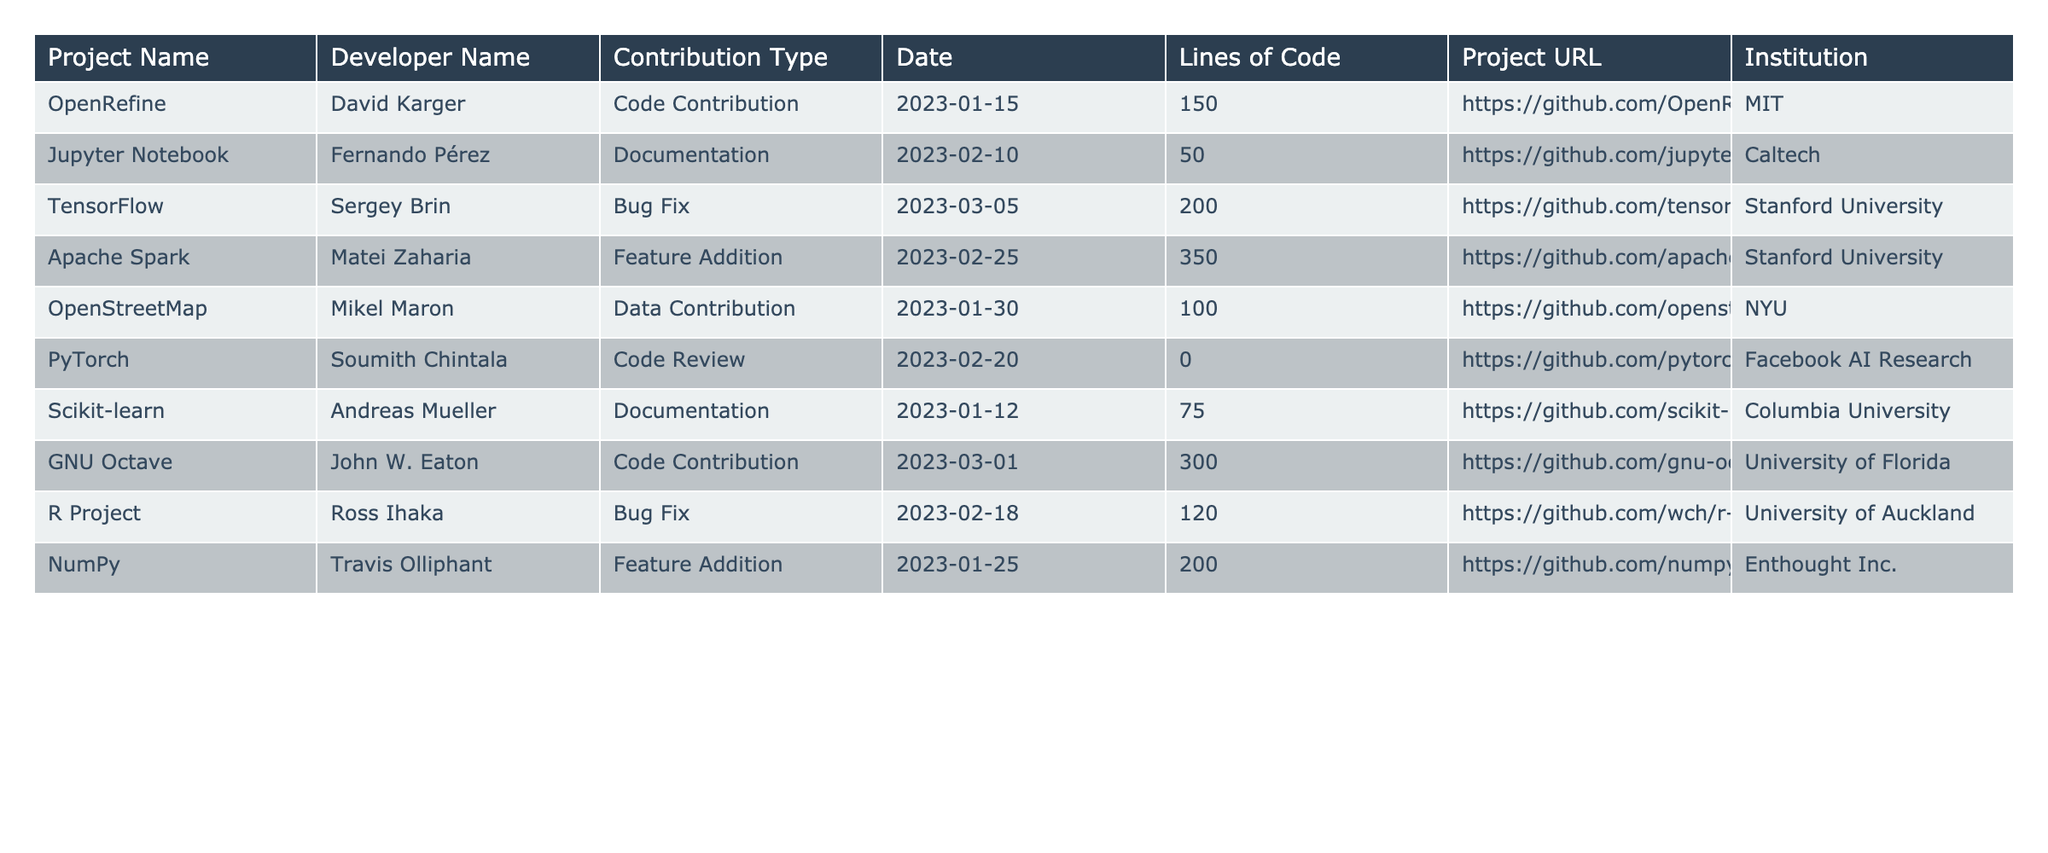What is the total number of lines of code contributed by David Karger in OpenRefine? David Karger contributed 150 lines of code in the OpenRefine project, as per the table entry for his contribution.
Answer: 150 Which project had the highest line of code contributed, and how many lines were contributed? The Apache Spark project had the highest line of code contributed, totaling 350 lines, based on the data presented in the table.
Answer: Apache Spark, 350 How many different types of contributions did Sergey Brin make? Sergey Brin made one contribution type, which is a bug fix, as there is only one entry for him in the table.
Answer: 1 Is there any documentation contribution from the University of Florida? No, there are no documentation contributions from the University of Florida listed in the table.
Answer: No What is the average number of lines of code contributed by all developers? To find the average, sum all the lines of code: 150 + 50 + 200 + 350 + 100 + 0 + 75 + 300 + 120 + 200 = 1,545. There are 10 developers, so divide 1,545 by 10, resulting in an average of 154.5 lines per developer.
Answer: 154.5 How many projects were contributed to by developers from Stanford University? Two projects were contributed to by developers from Stanford University: TensorFlow and Apache Spark, as seen in the institution column of the table.
Answer: 2 Which developer contributed the least lines of code and what was their contribution type? Soumith Chintala from Facebook AI Research contributed the least, with 0 lines of code in the form of a code review.
Answer: Soumith Chintala, Code Review Did any project contribute to more than one type of contribution? No, each project in the table has only one type of contribution listed, indicating that there are no mixed contribution types for any project.
Answer: No What was the total number of lines of code contributed by developers from NYU and Caltech? For NYU, Mikel Maron contributed 100 lines, and for Caltech, Fernando Pérez contributed 50 lines. Adding these gives a total of 150 lines from both institutions.
Answer: 150 Which institution has the most contributions listed in the table? Stanford University has the most contributions, with a total of two entries for both its projects (TensorFlow and Apache Spark) listed in the table.
Answer: Stanford University 